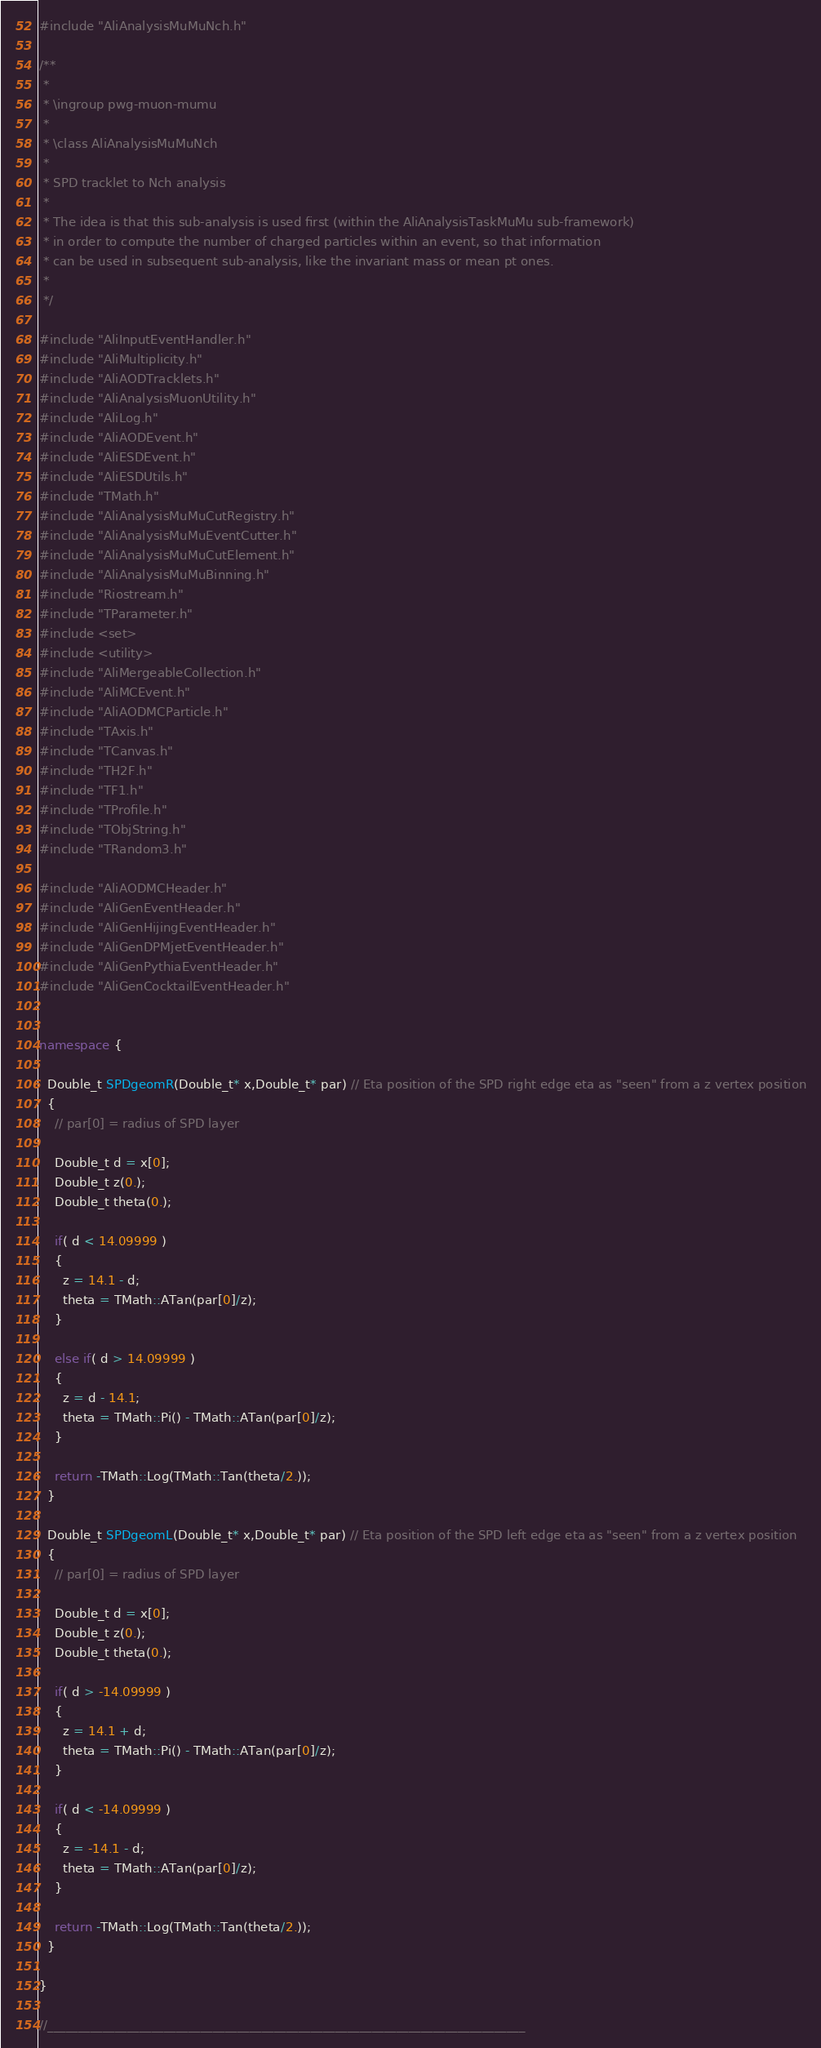<code> <loc_0><loc_0><loc_500><loc_500><_C++_>#include "AliAnalysisMuMuNch.h"

/**
 *
 * \ingroup pwg-muon-mumu
 *
 * \class AliAnalysisMuMuNch
 *
 * SPD tracklet to Nch analysis
 *
 * The idea is that this sub-analysis is used first (within the AliAnalysisTaskMuMu sub-framework)
 * in order to compute the number of charged particles within an event, so that information
 * can be used in subsequent sub-analysis, like the invariant mass or mean pt ones.
 *
 */

#include "AliInputEventHandler.h"
#include "AliMultiplicity.h"
#include "AliAODTracklets.h"
#include "AliAnalysisMuonUtility.h"
#include "AliLog.h"
#include "AliAODEvent.h"
#include "AliESDEvent.h"
#include "AliESDUtils.h"
#include "TMath.h"
#include "AliAnalysisMuMuCutRegistry.h"
#include "AliAnalysisMuMuEventCutter.h"
#include "AliAnalysisMuMuCutElement.h"
#include "AliAnalysisMuMuBinning.h"
#include "Riostream.h"
#include "TParameter.h"
#include <set>
#include <utility>
#include "AliMergeableCollection.h"
#include "AliMCEvent.h"
#include "AliAODMCParticle.h"
#include "TAxis.h"
#include "TCanvas.h"
#include "TH2F.h"
#include "TF1.h"
#include "TProfile.h"
#include "TObjString.h"
#include "TRandom3.h"

#include "AliAODMCHeader.h"
#include "AliGenEventHeader.h"
#include "AliGenHijingEventHeader.h"
#include "AliGenDPMjetEventHeader.h"
#include "AliGenPythiaEventHeader.h"
#include "AliGenCocktailEventHeader.h"


namespace {

  Double_t SPDgeomR(Double_t* x,Double_t* par) // Eta position of the SPD right edge eta as "seen" from a z vertex position
  {
    // par[0] = radius of SPD layer
    
    Double_t d = x[0];
    Double_t z(0.);
    Double_t theta(0.);
    
    if( d < 14.09999 )
    {
      z = 14.1 - d;
      theta = TMath::ATan(par[0]/z);
    }
    
    else if( d > 14.09999 )
    {
      z = d - 14.1;
      theta = TMath::Pi() - TMath::ATan(par[0]/z);
    }
    
    return -TMath::Log(TMath::Tan(theta/2.));
  }
  
  Double_t SPDgeomL(Double_t* x,Double_t* par) // Eta position of the SPD left edge eta as "seen" from a z vertex position
  {
    // par[0] = radius of SPD layer
    
    Double_t d = x[0];
    Double_t z(0.);
    Double_t theta(0.);
    
    if( d > -14.09999 )
    {
      z = 14.1 + d;
      theta = TMath::Pi() - TMath::ATan(par[0]/z);
    }
    
    if( d < -14.09999 )
    {
      z = -14.1 - d;
      theta = TMath::ATan(par[0]/z);
    }
    
    return -TMath::Log(TMath::Tan(theta/2.));
  }

}

//______________________________________________________________________________</code> 